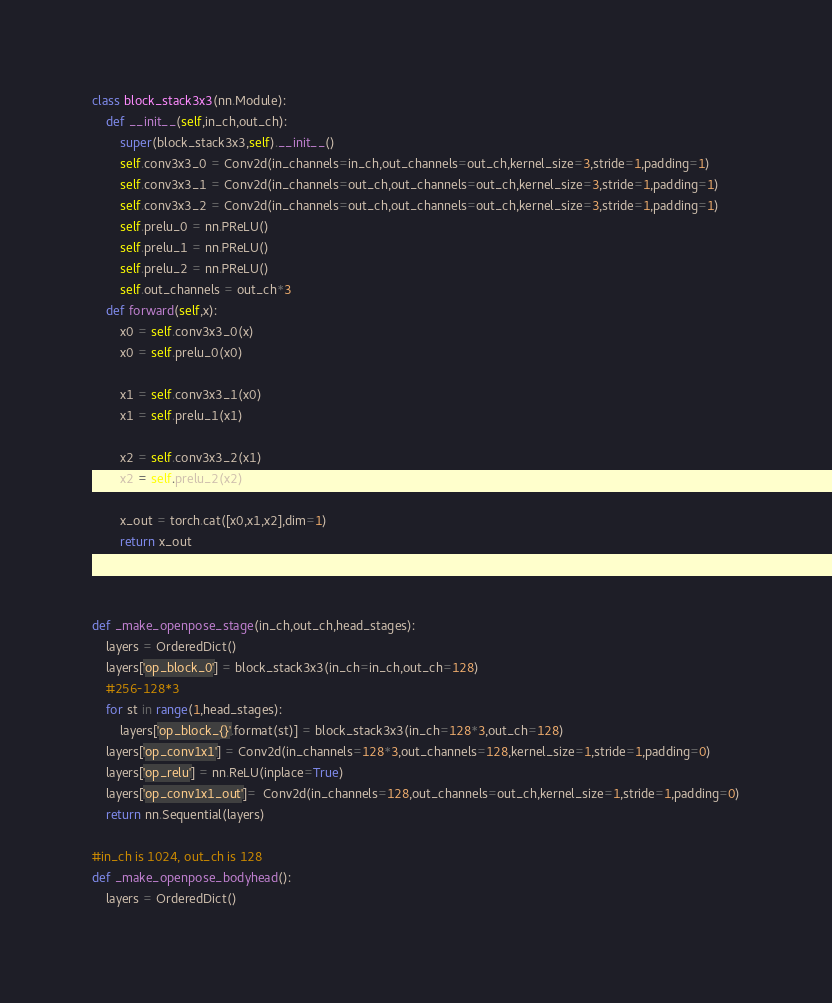Convert code to text. <code><loc_0><loc_0><loc_500><loc_500><_Python_>
class block_stack3x3(nn.Module):
    def __init__(self,in_ch,out_ch):
        super(block_stack3x3,self).__init__()
        self.conv3x3_0 = Conv2d(in_channels=in_ch,out_channels=out_ch,kernel_size=3,stride=1,padding=1)
        self.conv3x3_1 = Conv2d(in_channels=out_ch,out_channels=out_ch,kernel_size=3,stride=1,padding=1)
        self.conv3x3_2 = Conv2d(in_channels=out_ch,out_channels=out_ch,kernel_size=3,stride=1,padding=1)
        self.prelu_0 = nn.PReLU()
        self.prelu_1 = nn.PReLU()
        self.prelu_2 = nn.PReLU()
        self.out_channels = out_ch*3
    def forward(self,x):
        x0 = self.conv3x3_0(x)
        x0 = self.prelu_0(x0)

        x1 = self.conv3x3_1(x0)
        x1 = self.prelu_1(x1)

        x2 = self.conv3x3_2(x1)
        x2 = self.prelu_2(x2)

        x_out = torch.cat([x0,x1,x2],dim=1)
        return x_out



def _make_openpose_stage(in_ch,out_ch,head_stages):
    layers = OrderedDict()
    layers['op_block_0'] = block_stack3x3(in_ch=in_ch,out_ch=128)
    #256-128*3
    for st in range(1,head_stages):
        layers['op_block_{}'.format(st)] = block_stack3x3(in_ch=128*3,out_ch=128)
    layers['op_conv1x1'] = Conv2d(in_channels=128*3,out_channels=128,kernel_size=1,stride=1,padding=0)
    layers['op_relu'] = nn.ReLU(inplace=True)
    layers['op_conv1x1_out']=  Conv2d(in_channels=128,out_channels=out_ch,kernel_size=1,stride=1,padding=0)
    return nn.Sequential(layers)

#in_ch is 1024, out_ch is 128
def _make_openpose_bodyhead():
    layers = OrderedDict()</code> 